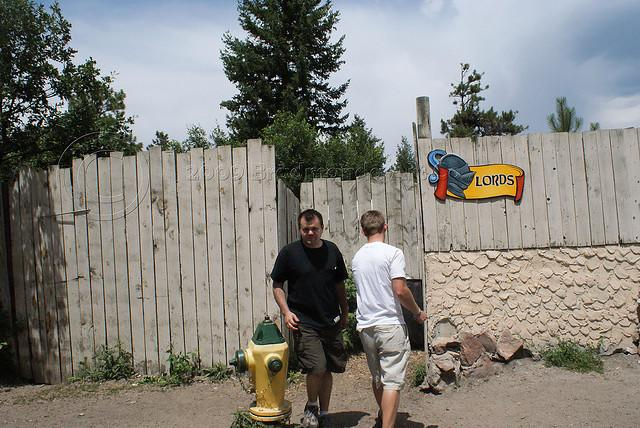What does the man in white need to use? bathroom 